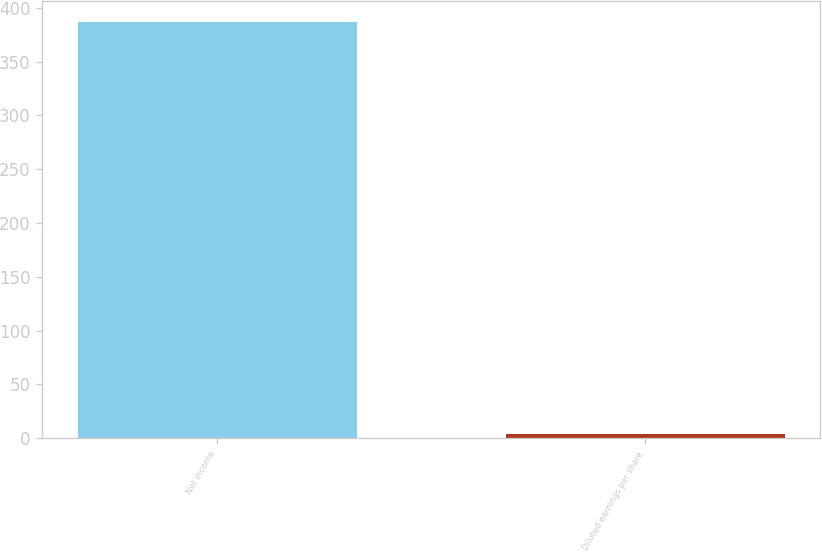Convert chart to OTSL. <chart><loc_0><loc_0><loc_500><loc_500><bar_chart><fcel>Net income<fcel>Diluted earnings per share<nl><fcel>387<fcel>3.64<nl></chart> 